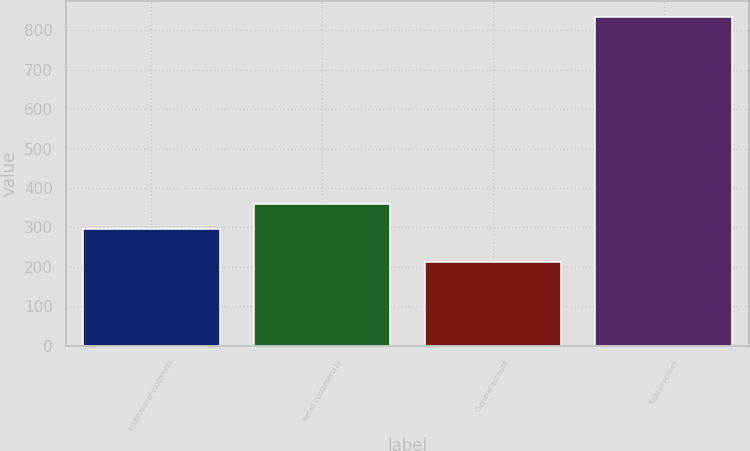<chart> <loc_0><loc_0><loc_500><loc_500><bar_chart><fcel>Institutional customers<fcel>Retail customers(1)<fcel>General account<fcel>Total revenues<nl><fcel>297<fcel>358.9<fcel>213<fcel>832<nl></chart> 